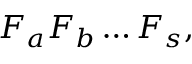Convert formula to latex. <formula><loc_0><loc_0><loc_500><loc_500>F _ { a } F _ { b } \dots F _ { s } ,</formula> 